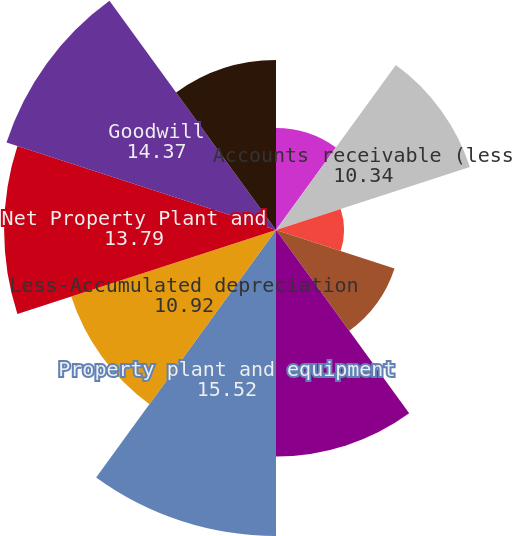Convert chart. <chart><loc_0><loc_0><loc_500><loc_500><pie_chart><fcel>Cash and cash equivalents<fcel>Accounts receivable (less<fcel>Deferred income taxes<fcel>Prepaid expenses and other<fcel>Total Current Assets<fcel>Property plant and equipment<fcel>Less-Accumulated depreciation<fcel>Net Property Plant and<fcel>Goodwill<fcel>Customer relationships and<nl><fcel>5.17%<fcel>10.34%<fcel>3.45%<fcel>6.32%<fcel>11.49%<fcel>15.52%<fcel>10.92%<fcel>13.79%<fcel>14.37%<fcel>8.62%<nl></chart> 